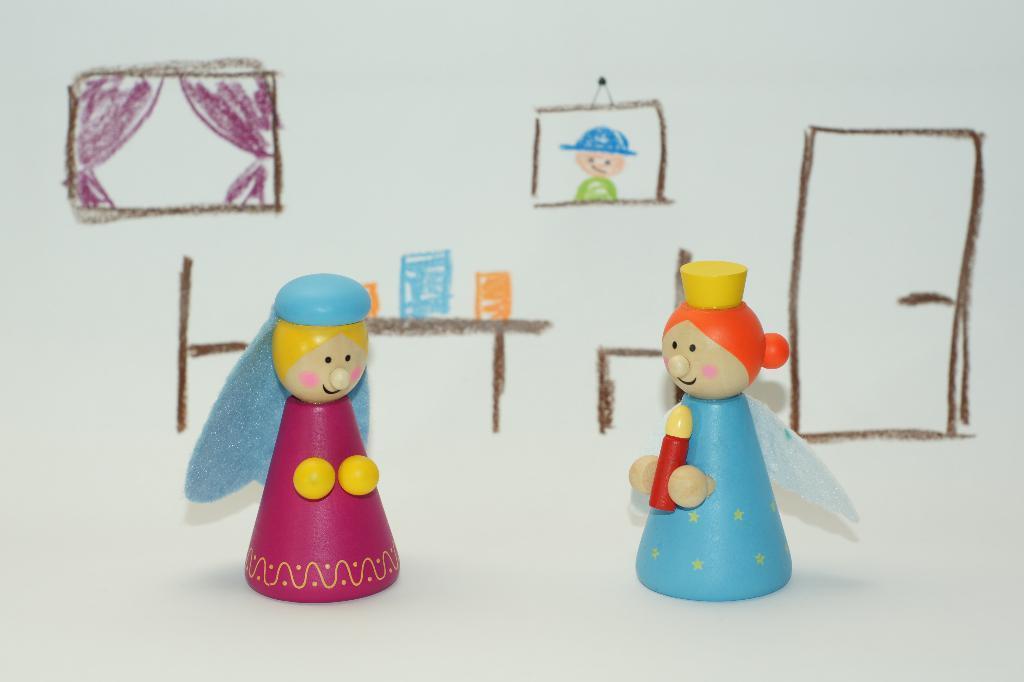Could you give a brief overview of what you see in this image? In this image there is a drawing in the paper with crayons, also there are two dolls. 